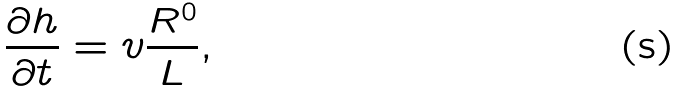<formula> <loc_0><loc_0><loc_500><loc_500>\frac { \partial h } { \partial t } = v \frac { R ^ { 0 } } { L } ,</formula> 